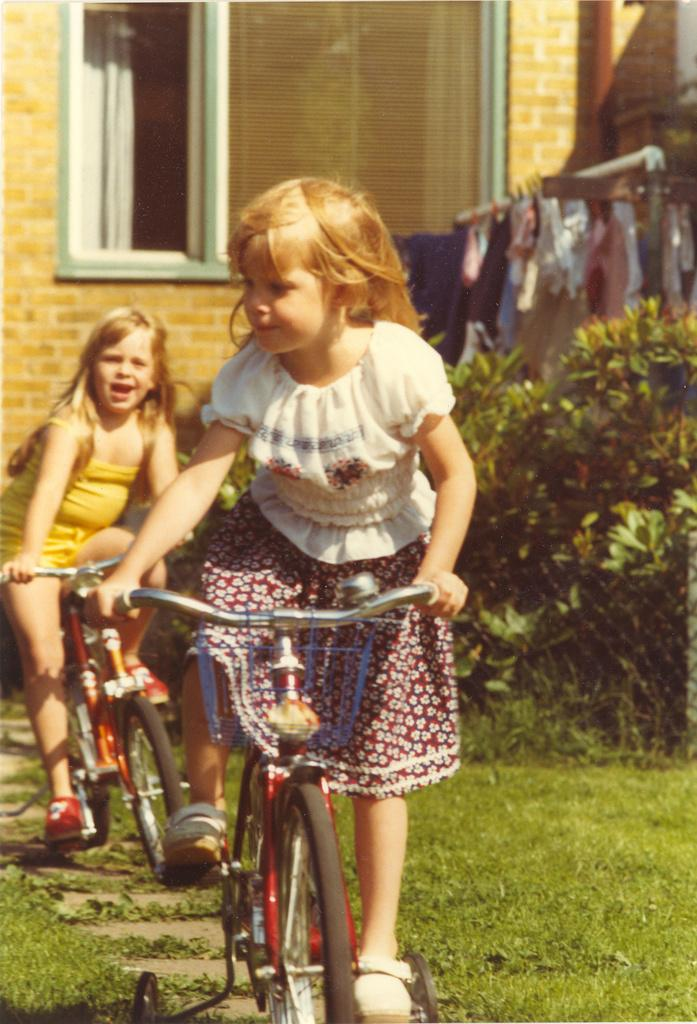How many girls are in the image? There are 2 girls in the image. What are the girls doing in the image? The girls are on cycles. What type of terrain is visible in the image? There is grass visible in the image. What can be seen in the background of the image? There are plants, a wall, a window, and clothes visible in the background of the image. What type of event is the fireman attending in the image? There is no fireman present in the image, so it is not possible to determine what event they might be attending. How many bees can be seen buzzing around the girls in the image? There are no bees visible in the image; the girls are on cycles and there are no insects mentioned in the provided facts. 